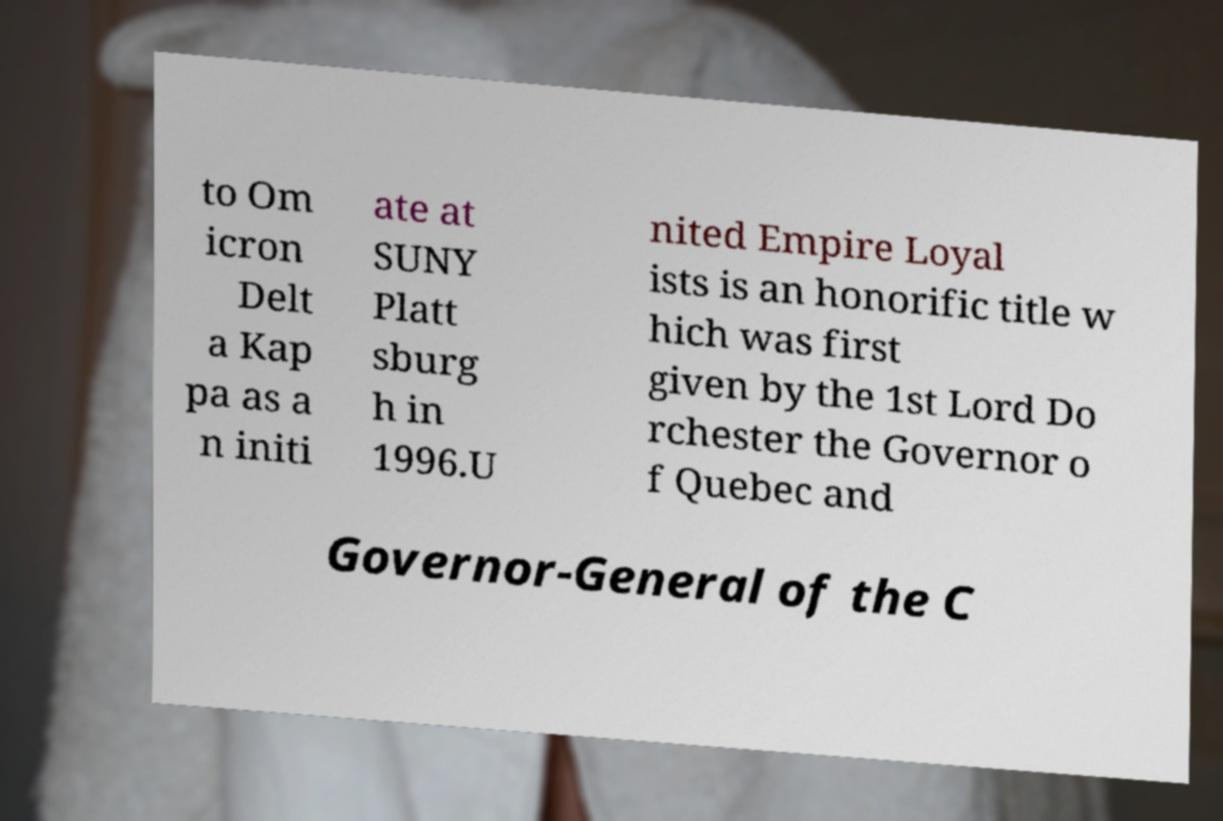Can you accurately transcribe the text from the provided image for me? to Om icron Delt a Kap pa as a n initi ate at SUNY Platt sburg h in 1996.U nited Empire Loyal ists is an honorific title w hich was first given by the 1st Lord Do rchester the Governor o f Quebec and Governor-General of the C 